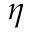Convert formula to latex. <formula><loc_0><loc_0><loc_500><loc_500>\eta</formula> 